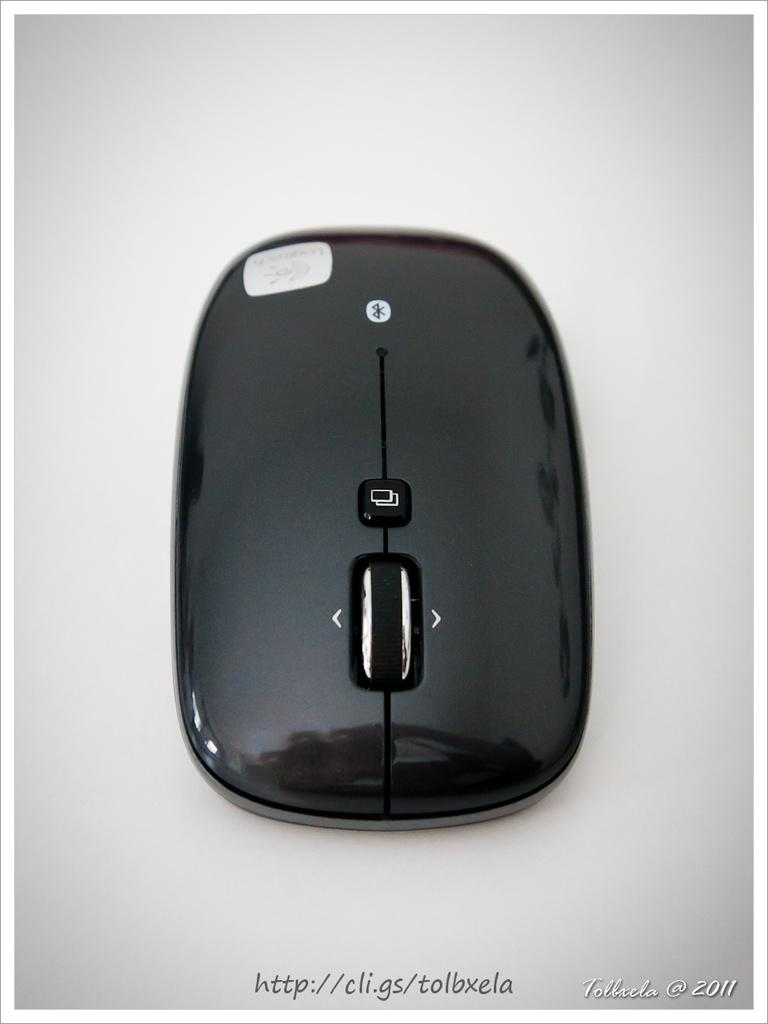<image>
Offer a succinct explanation of the picture presented. An electronic device is labelled with the website http://cli.gs/tolbxela and is dated 2011. 